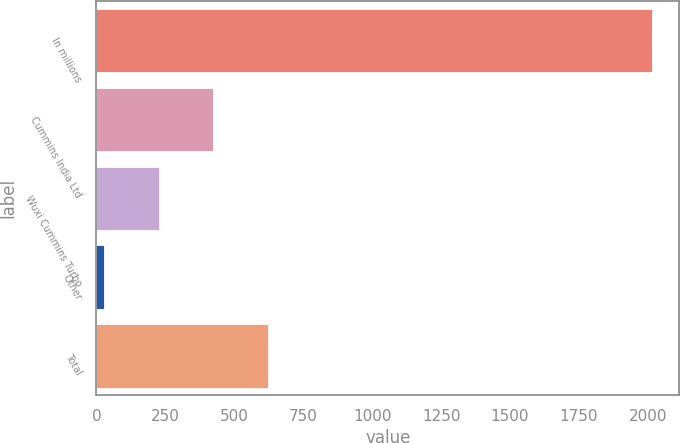<chart> <loc_0><loc_0><loc_500><loc_500><bar_chart><fcel>In millions<fcel>Cummins India Ltd<fcel>Wuxi Cummins Turbo<fcel>Other<fcel>Total<nl><fcel>2013<fcel>424.2<fcel>225.6<fcel>27<fcel>622.8<nl></chart> 